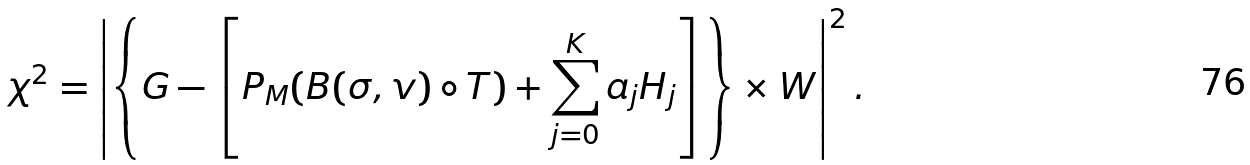<formula> <loc_0><loc_0><loc_500><loc_500>\chi ^ { 2 } = \left | \left \{ G - \left [ P _ { M } ( B ( \sigma , v ) \circ T ) + \sum _ { j = 0 } ^ { K } a _ { j } H _ { j } \right ] \right \} \times W \right | ^ { 2 } .</formula> 